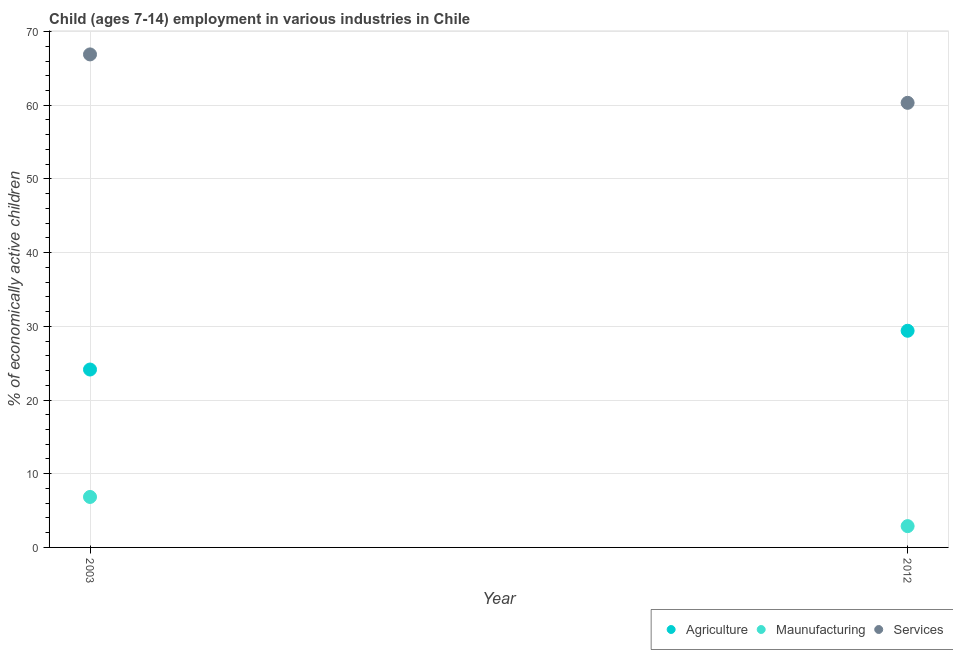What is the percentage of economically active children in agriculture in 2003?
Ensure brevity in your answer.  24.14. Across all years, what is the maximum percentage of economically active children in manufacturing?
Offer a very short reply. 6.85. Across all years, what is the minimum percentage of economically active children in agriculture?
Your answer should be compact. 24.14. In which year was the percentage of economically active children in manufacturing minimum?
Make the answer very short. 2012. What is the total percentage of economically active children in agriculture in the graph?
Provide a short and direct response. 53.54. What is the difference between the percentage of economically active children in services in 2003 and that in 2012?
Make the answer very short. 6.57. What is the difference between the percentage of economically active children in services in 2003 and the percentage of economically active children in manufacturing in 2012?
Your answer should be very brief. 64.01. What is the average percentage of economically active children in manufacturing per year?
Ensure brevity in your answer.  4.87. In the year 2012, what is the difference between the percentage of economically active children in services and percentage of economically active children in manufacturing?
Give a very brief answer. 57.44. In how many years, is the percentage of economically active children in manufacturing greater than 48 %?
Your response must be concise. 0. What is the ratio of the percentage of economically active children in manufacturing in 2003 to that in 2012?
Provide a succinct answer. 2.37. Is the percentage of economically active children in services in 2003 less than that in 2012?
Your answer should be compact. No. In how many years, is the percentage of economically active children in agriculture greater than the average percentage of economically active children in agriculture taken over all years?
Offer a very short reply. 1. Is it the case that in every year, the sum of the percentage of economically active children in agriculture and percentage of economically active children in manufacturing is greater than the percentage of economically active children in services?
Your answer should be compact. No. Is the percentage of economically active children in services strictly greater than the percentage of economically active children in manufacturing over the years?
Provide a succinct answer. Yes. Is the percentage of economically active children in services strictly less than the percentage of economically active children in manufacturing over the years?
Make the answer very short. No. How many legend labels are there?
Provide a succinct answer. 3. What is the title of the graph?
Provide a short and direct response. Child (ages 7-14) employment in various industries in Chile. Does "Ages 0-14" appear as one of the legend labels in the graph?
Your answer should be very brief. No. What is the label or title of the X-axis?
Your answer should be compact. Year. What is the label or title of the Y-axis?
Give a very brief answer. % of economically active children. What is the % of economically active children of Agriculture in 2003?
Provide a succinct answer. 24.14. What is the % of economically active children of Maunufacturing in 2003?
Give a very brief answer. 6.85. What is the % of economically active children of Services in 2003?
Your answer should be very brief. 66.9. What is the % of economically active children in Agriculture in 2012?
Offer a very short reply. 29.4. What is the % of economically active children in Maunufacturing in 2012?
Provide a short and direct response. 2.89. What is the % of economically active children in Services in 2012?
Your answer should be compact. 60.33. Across all years, what is the maximum % of economically active children of Agriculture?
Give a very brief answer. 29.4. Across all years, what is the maximum % of economically active children of Maunufacturing?
Keep it short and to the point. 6.85. Across all years, what is the maximum % of economically active children of Services?
Make the answer very short. 66.9. Across all years, what is the minimum % of economically active children of Agriculture?
Your answer should be very brief. 24.14. Across all years, what is the minimum % of economically active children in Maunufacturing?
Your response must be concise. 2.89. Across all years, what is the minimum % of economically active children in Services?
Give a very brief answer. 60.33. What is the total % of economically active children of Agriculture in the graph?
Give a very brief answer. 53.54. What is the total % of economically active children of Maunufacturing in the graph?
Ensure brevity in your answer.  9.74. What is the total % of economically active children in Services in the graph?
Offer a very short reply. 127.23. What is the difference between the % of economically active children of Agriculture in 2003 and that in 2012?
Your response must be concise. -5.26. What is the difference between the % of economically active children of Maunufacturing in 2003 and that in 2012?
Keep it short and to the point. 3.96. What is the difference between the % of economically active children in Services in 2003 and that in 2012?
Make the answer very short. 6.57. What is the difference between the % of economically active children of Agriculture in 2003 and the % of economically active children of Maunufacturing in 2012?
Your answer should be very brief. 21.25. What is the difference between the % of economically active children of Agriculture in 2003 and the % of economically active children of Services in 2012?
Ensure brevity in your answer.  -36.19. What is the difference between the % of economically active children of Maunufacturing in 2003 and the % of economically active children of Services in 2012?
Provide a short and direct response. -53.48. What is the average % of economically active children in Agriculture per year?
Your answer should be compact. 26.77. What is the average % of economically active children of Maunufacturing per year?
Offer a very short reply. 4.87. What is the average % of economically active children in Services per year?
Offer a terse response. 63.62. In the year 2003, what is the difference between the % of economically active children of Agriculture and % of economically active children of Maunufacturing?
Your answer should be very brief. 17.29. In the year 2003, what is the difference between the % of economically active children of Agriculture and % of economically active children of Services?
Ensure brevity in your answer.  -42.76. In the year 2003, what is the difference between the % of economically active children of Maunufacturing and % of economically active children of Services?
Offer a terse response. -60.05. In the year 2012, what is the difference between the % of economically active children of Agriculture and % of economically active children of Maunufacturing?
Your response must be concise. 26.51. In the year 2012, what is the difference between the % of economically active children in Agriculture and % of economically active children in Services?
Give a very brief answer. -30.93. In the year 2012, what is the difference between the % of economically active children of Maunufacturing and % of economically active children of Services?
Offer a terse response. -57.44. What is the ratio of the % of economically active children of Agriculture in 2003 to that in 2012?
Make the answer very short. 0.82. What is the ratio of the % of economically active children in Maunufacturing in 2003 to that in 2012?
Offer a terse response. 2.37. What is the ratio of the % of economically active children in Services in 2003 to that in 2012?
Provide a short and direct response. 1.11. What is the difference between the highest and the second highest % of economically active children in Agriculture?
Offer a very short reply. 5.26. What is the difference between the highest and the second highest % of economically active children of Maunufacturing?
Ensure brevity in your answer.  3.96. What is the difference between the highest and the second highest % of economically active children in Services?
Offer a terse response. 6.57. What is the difference between the highest and the lowest % of economically active children in Agriculture?
Offer a terse response. 5.26. What is the difference between the highest and the lowest % of economically active children in Maunufacturing?
Your answer should be compact. 3.96. What is the difference between the highest and the lowest % of economically active children of Services?
Your answer should be compact. 6.57. 